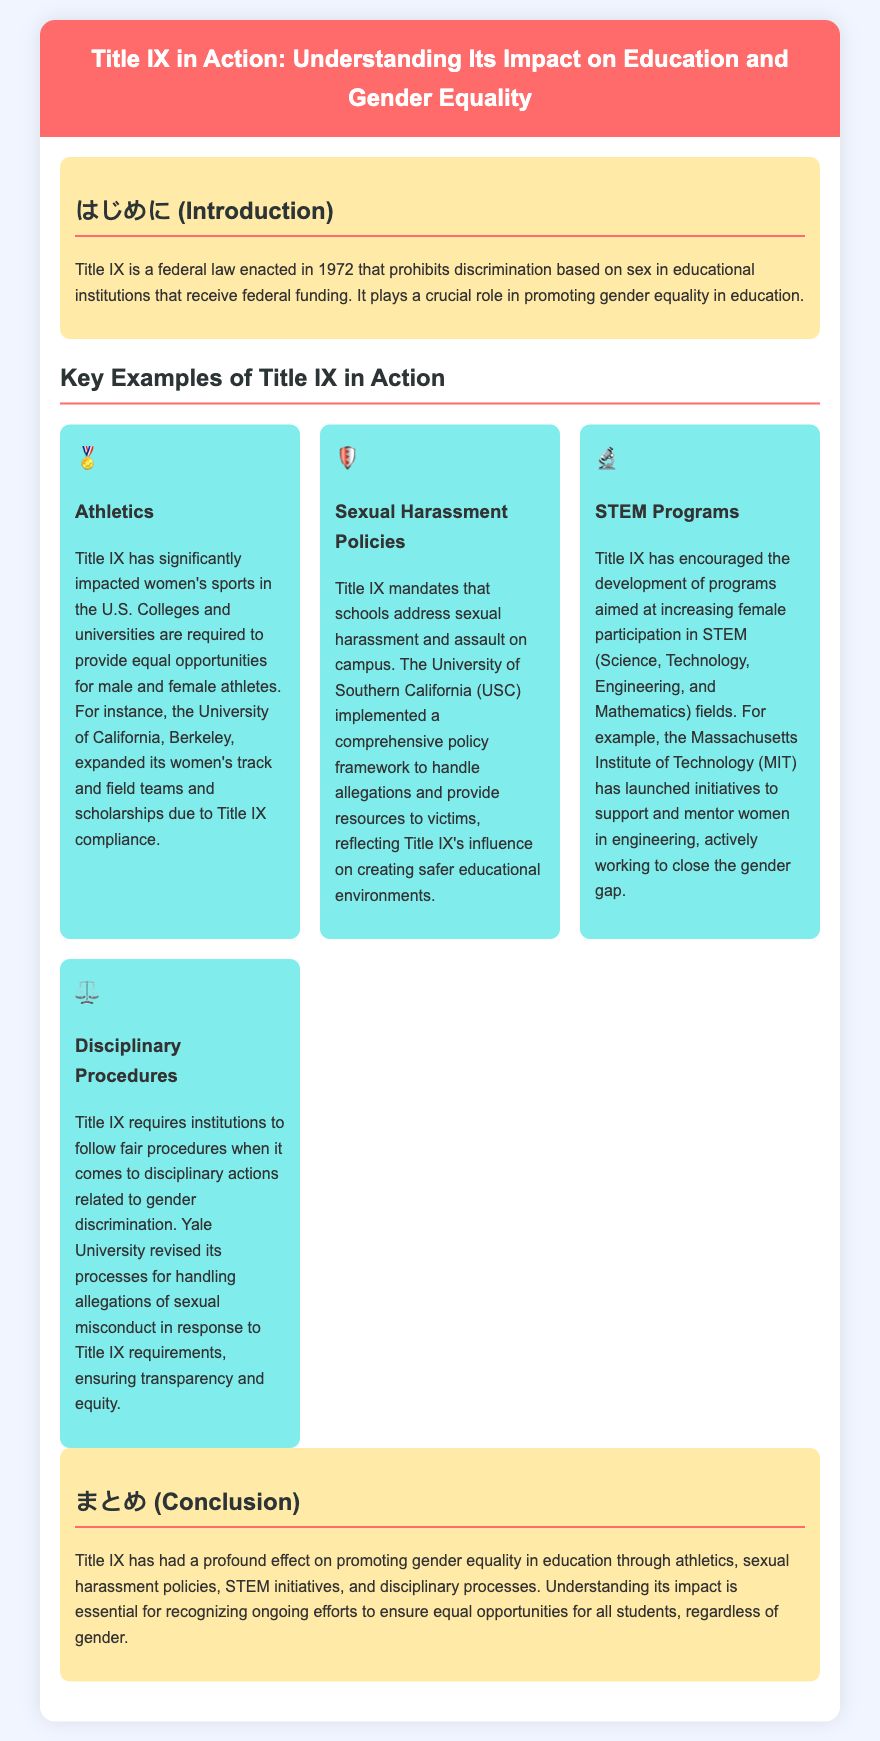what year was Title IX enacted? The document states that Title IX was enacted in 1972.
Answer: 1972 what does Title IX prohibit? The introduction explains that Title IX prohibits discrimination based on sex in educational institutions receiving federal funding.
Answer: discrimination based on sex which university expanded its women's track and field teams due to Title IX? The document mentions that the University of California, Berkeley, expanded its women's track and field teams and scholarships.
Answer: University of California, Berkeley what does Title IX mandate regarding sexual harassment? The document states that Title IX mandates schools to address sexual harassment and assault on campus.
Answer: address sexual harassment which institution launched initiatives to support women in engineering? The examples mention that the Massachusetts Institute of Technology (MIT) has launched initiatives to support and mentor women in engineering.
Answer: Massachusetts Institute of Technology what aspect of gender equality does Title IX influence in the disciplinary procedures? The document indicates that Title IX requires institutions to follow fair procedures in disciplinary actions related to gender discrimination.
Answer: fair procedures what is the main focus of the concluding paragraph? The conclusion states that Title IX has had a profound effect on promoting gender equality in education through various areas.
Answer: promoting gender equality what symbol is associated with athletics in the examples? Each example in the document has an icon; the symbol for athletics is a medal (🏅).
Answer: 🏅 